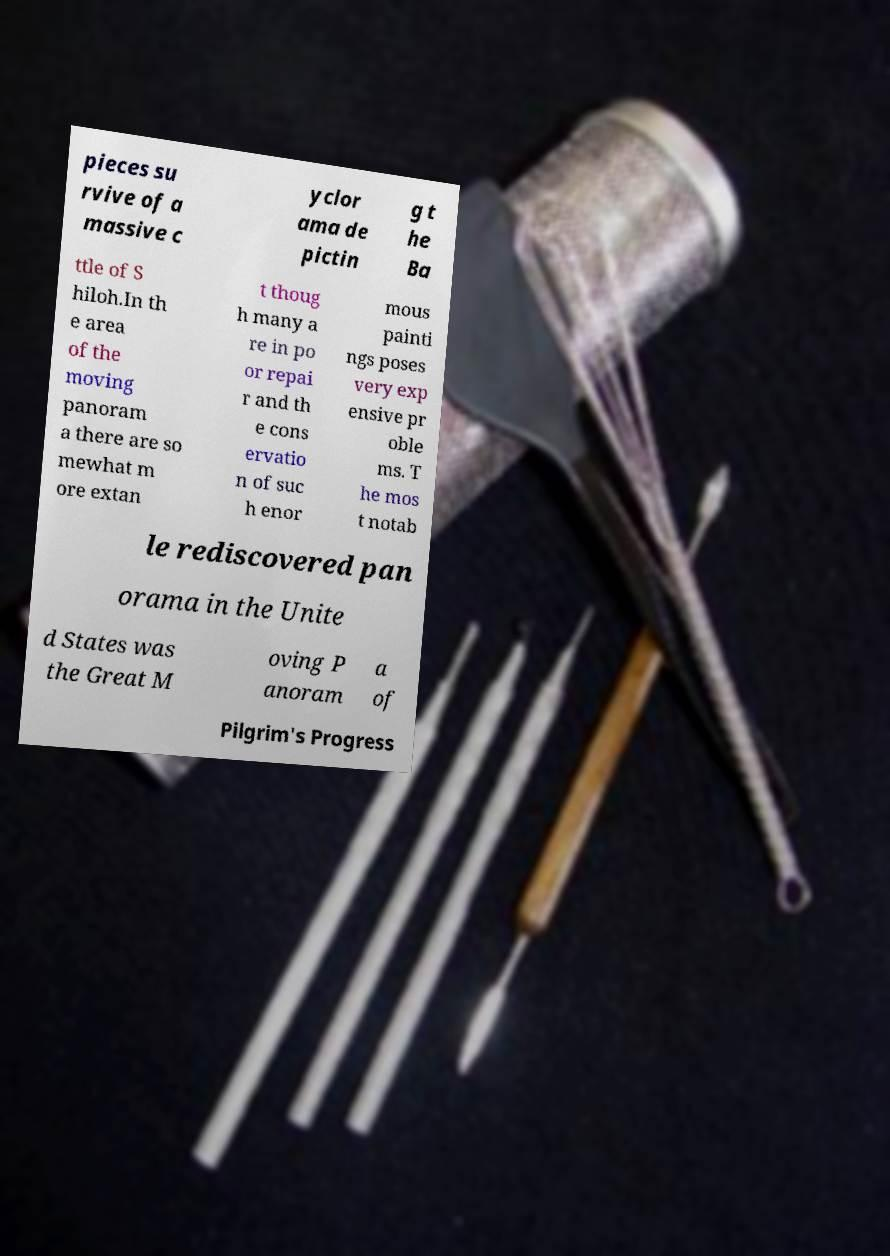Can you accurately transcribe the text from the provided image for me? pieces su rvive of a massive c yclor ama de pictin g t he Ba ttle of S hiloh.In th e area of the moving panoram a there are so mewhat m ore extan t thoug h many a re in po or repai r and th e cons ervatio n of suc h enor mous painti ngs poses very exp ensive pr oble ms. T he mos t notab le rediscovered pan orama in the Unite d States was the Great M oving P anoram a of Pilgrim's Progress 